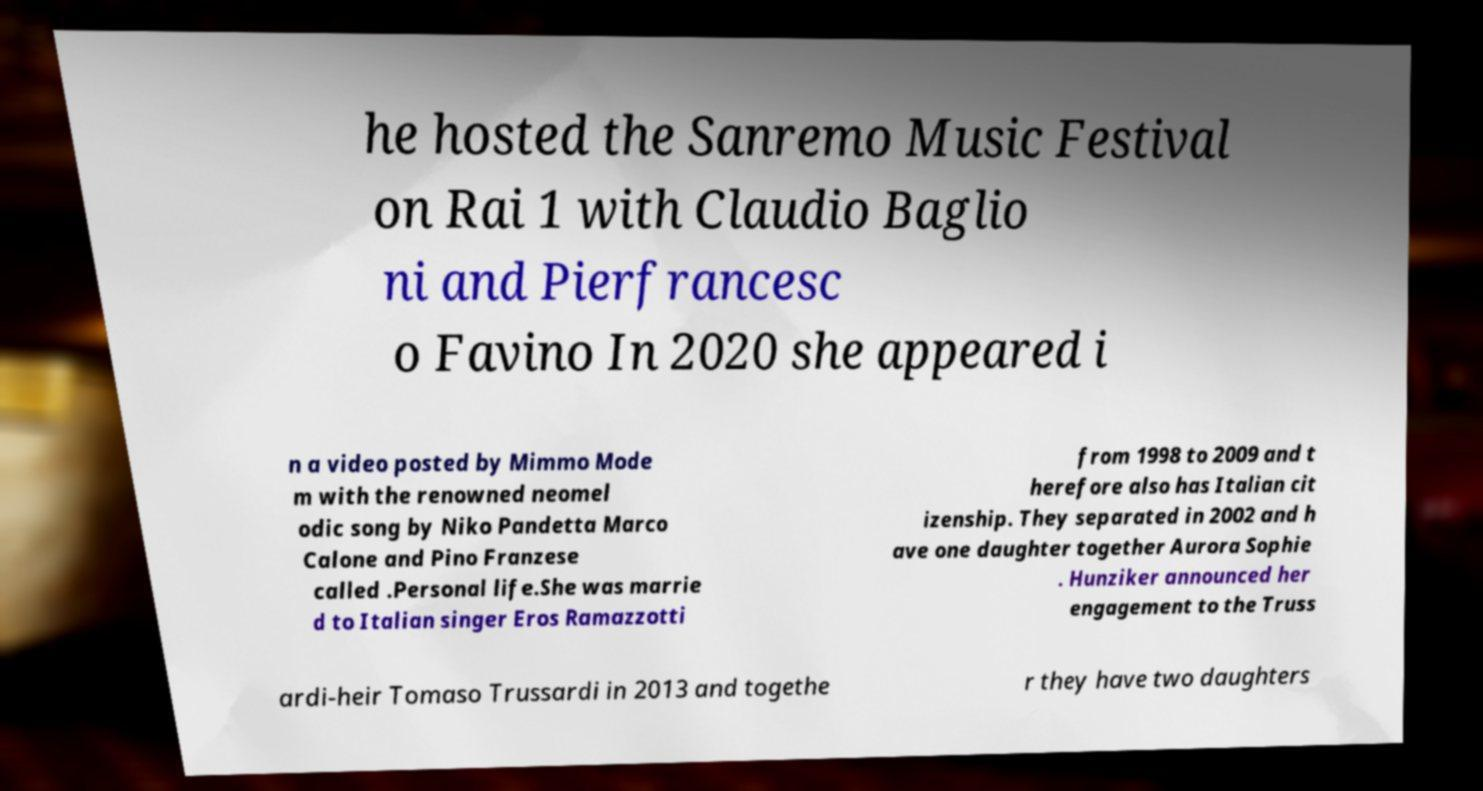Please read and relay the text visible in this image. What does it say? he hosted the Sanremo Music Festival on Rai 1 with Claudio Baglio ni and Pierfrancesc o Favino In 2020 she appeared i n a video posted by Mimmo Mode m with the renowned neomel odic song by Niko Pandetta Marco Calone and Pino Franzese called .Personal life.She was marrie d to Italian singer Eros Ramazzotti from 1998 to 2009 and t herefore also has Italian cit izenship. They separated in 2002 and h ave one daughter together Aurora Sophie . Hunziker announced her engagement to the Truss ardi-heir Tomaso Trussardi in 2013 and togethe r they have two daughters 